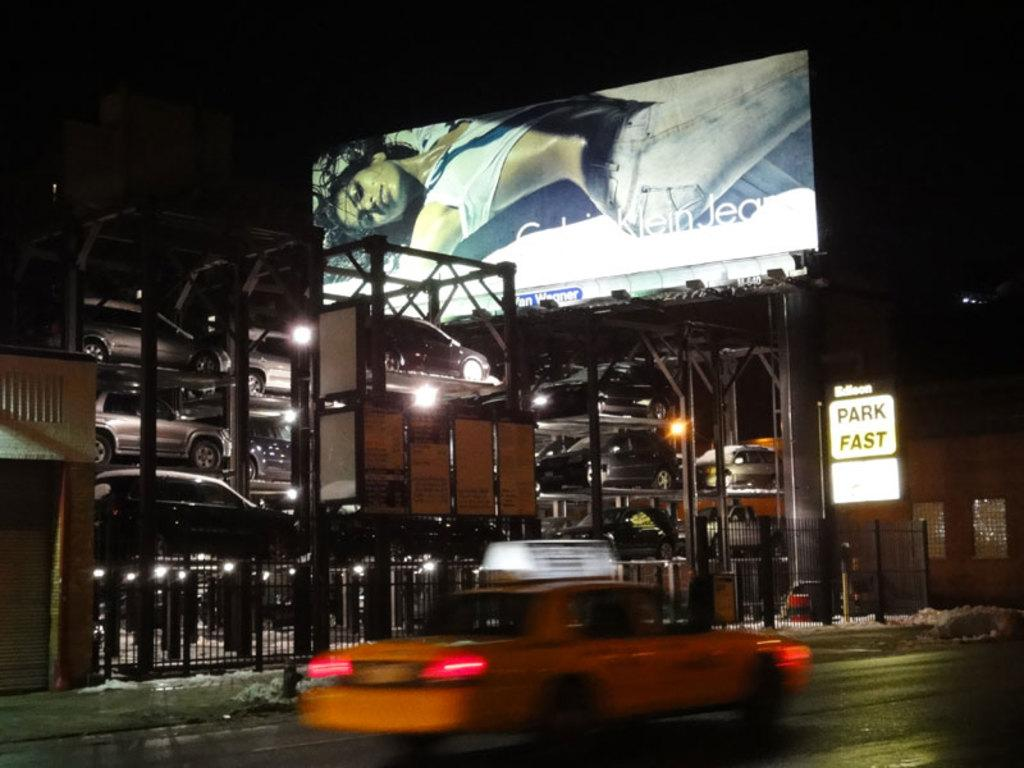<image>
Create a compact narrative representing the image presented. A multistory parking structure in NYC goes by the name Park Fast. 